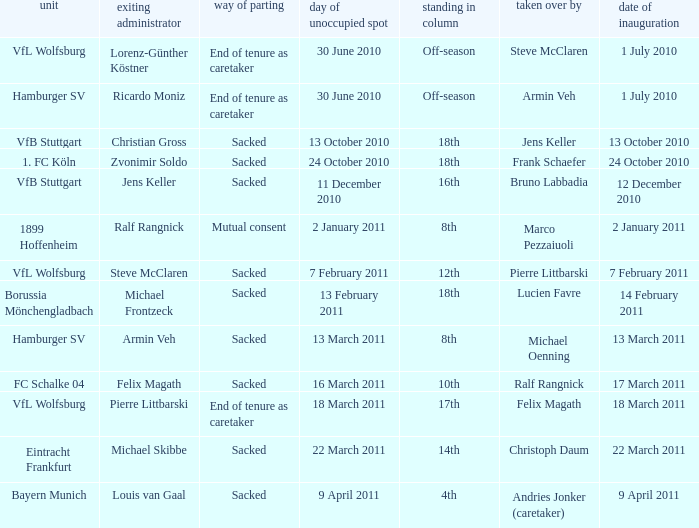When steve mcclaren is the replacer what is the manner of departure? End of tenure as caretaker. 